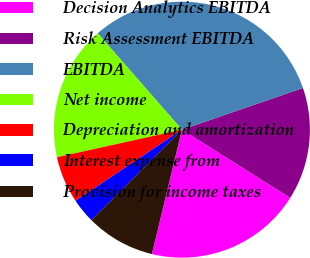Convert chart to OTSL. <chart><loc_0><loc_0><loc_500><loc_500><pie_chart><fcel>Decision Analytics EBITDA<fcel>Risk Assessment EBITDA<fcel>EBITDA<fcel>Net income<fcel>Depreciation and amortization<fcel>Interest expense from<fcel>Provision for income taxes<nl><fcel>19.83%<fcel>14.22%<fcel>31.16%<fcel>17.02%<fcel>5.92%<fcel>3.12%<fcel>8.73%<nl></chart> 